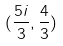<formula> <loc_0><loc_0><loc_500><loc_500>( \frac { 5 i } { 3 } , \frac { 4 } { 3 } )</formula> 